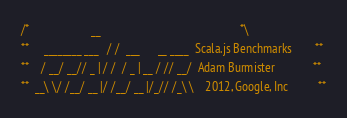<code> <loc_0><loc_0><loc_500><loc_500><_Scala_>/*                     __                                               *\
**     ________ ___   / /  ___      __ ____  Scala.js Benchmarks        **
**    / __/ __// _ | / /  / _ | __ / // __/  Adam Burmister             **
**  __\ \/ /__/ __ |/ /__/ __ |/_// /_\ \    2012, Google, Inc          **</code> 